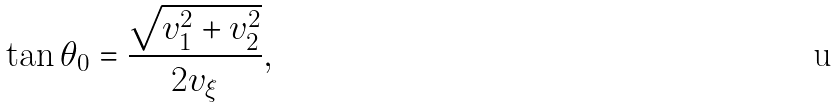Convert formula to latex. <formula><loc_0><loc_0><loc_500><loc_500>\tan \theta _ { 0 } = \frac { \sqrt { v _ { 1 } ^ { 2 } + v _ { 2 } ^ { 2 } } } { 2 v _ { \xi } } ,</formula> 